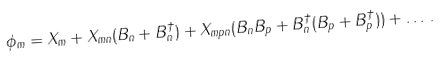<formula> <loc_0><loc_0><loc_500><loc_500>\phi _ { m } = X _ { m } + X _ { m n } ( B _ { n } + B _ { n } ^ { \dagger } ) + X _ { m p n } ( B _ { n } B _ { p } + B _ { n } ^ { \dagger } ( B _ { p } + B _ { p } ^ { \dagger } ) ) + \dots \, .</formula> 